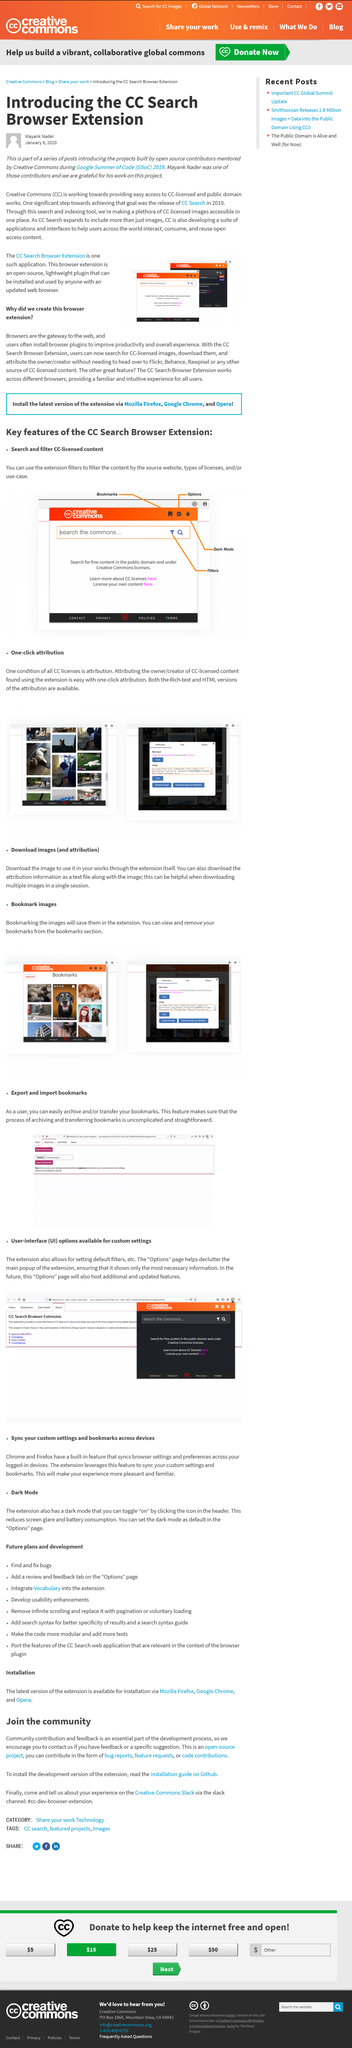Indicate a few pertinent items in this graphic. In the article, CC refers to Creative Commons, a type of licensing used to allow the sharing and use of content while still protecting the rights of the creator. You can share your experience with the group in the Slack channel by providing valuable insights that can benefit everyone. The development version is installed using a specific service that can be found through Github. This post was written on January 6, 2020, as evident from the timestamp. Mayank Nader wrote the post about the CC Search Browser Extension. 